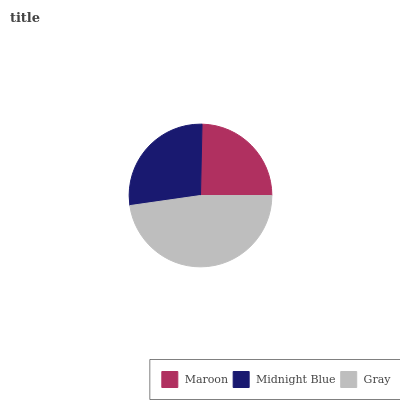Is Maroon the minimum?
Answer yes or no. Yes. Is Gray the maximum?
Answer yes or no. Yes. Is Midnight Blue the minimum?
Answer yes or no. No. Is Midnight Blue the maximum?
Answer yes or no. No. Is Midnight Blue greater than Maroon?
Answer yes or no. Yes. Is Maroon less than Midnight Blue?
Answer yes or no. Yes. Is Maroon greater than Midnight Blue?
Answer yes or no. No. Is Midnight Blue less than Maroon?
Answer yes or no. No. Is Midnight Blue the high median?
Answer yes or no. Yes. Is Midnight Blue the low median?
Answer yes or no. Yes. Is Gray the high median?
Answer yes or no. No. Is Maroon the low median?
Answer yes or no. No. 